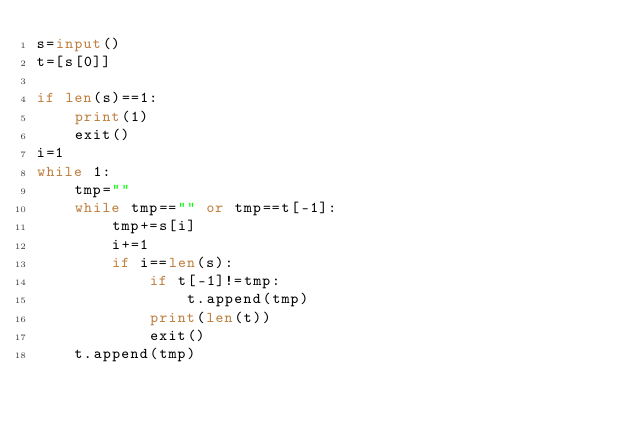Convert code to text. <code><loc_0><loc_0><loc_500><loc_500><_Python_>s=input()
t=[s[0]]

if len(s)==1:
    print(1)
    exit()
i=1
while 1:
    tmp=""
    while tmp=="" or tmp==t[-1]:
        tmp+=s[i]
        i+=1
        if i==len(s):
            if t[-1]!=tmp:
                t.append(tmp)
            print(len(t))
            exit()
    t.append(tmp)
</code> 